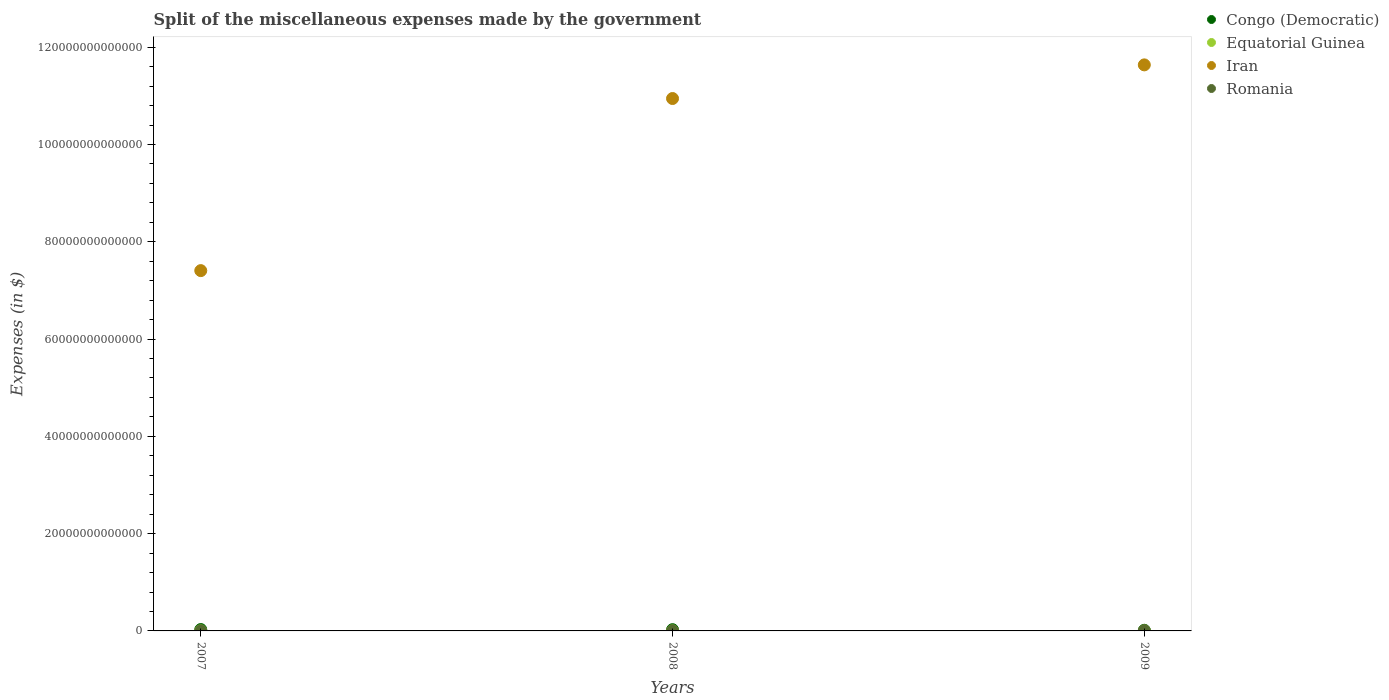What is the miscellaneous expenses made by the government in Iran in 2009?
Keep it short and to the point. 1.16e+14. Across all years, what is the maximum miscellaneous expenses made by the government in Congo (Democratic)?
Ensure brevity in your answer.  2.81e+11. Across all years, what is the minimum miscellaneous expenses made by the government in Romania?
Make the answer very short. 1.36e+1. In which year was the miscellaneous expenses made by the government in Romania maximum?
Give a very brief answer. 2009. In which year was the miscellaneous expenses made by the government in Congo (Democratic) minimum?
Provide a succinct answer. 2009. What is the total miscellaneous expenses made by the government in Equatorial Guinea in the graph?
Your answer should be compact. 2.29e+1. What is the difference between the miscellaneous expenses made by the government in Equatorial Guinea in 2007 and that in 2008?
Provide a succinct answer. -5.30e+07. What is the difference between the miscellaneous expenses made by the government in Equatorial Guinea in 2007 and the miscellaneous expenses made by the government in Romania in 2008?
Your answer should be very brief. -4.41e+09. What is the average miscellaneous expenses made by the government in Romania per year?
Your response must be concise. 2.50e+1. In the year 2008, what is the difference between the miscellaneous expenses made by the government in Iran and miscellaneous expenses made by the government in Equatorial Guinea?
Offer a very short reply. 1.09e+14. In how many years, is the miscellaneous expenses made by the government in Equatorial Guinea greater than 44000000000000 $?
Your answer should be very brief. 0. What is the ratio of the miscellaneous expenses made by the government in Romania in 2007 to that in 2009?
Give a very brief answer. 0.31. Is the miscellaneous expenses made by the government in Congo (Democratic) in 2007 less than that in 2008?
Provide a succinct answer. No. What is the difference between the highest and the second highest miscellaneous expenses made by the government in Congo (Democratic)?
Offer a very short reply. 2.54e+1. What is the difference between the highest and the lowest miscellaneous expenses made by the government in Congo (Democratic)?
Offer a terse response. 1.52e+11. Is the sum of the miscellaneous expenses made by the government in Iran in 2007 and 2009 greater than the maximum miscellaneous expenses made by the government in Congo (Democratic) across all years?
Provide a short and direct response. Yes. Is it the case that in every year, the sum of the miscellaneous expenses made by the government in Congo (Democratic) and miscellaneous expenses made by the government in Equatorial Guinea  is greater than the sum of miscellaneous expenses made by the government in Romania and miscellaneous expenses made by the government in Iran?
Give a very brief answer. Yes. Is it the case that in every year, the sum of the miscellaneous expenses made by the government in Congo (Democratic) and miscellaneous expenses made by the government in Iran  is greater than the miscellaneous expenses made by the government in Equatorial Guinea?
Your response must be concise. Yes. Does the miscellaneous expenses made by the government in Congo (Democratic) monotonically increase over the years?
Provide a short and direct response. No. How many dotlines are there?
Offer a very short reply. 4. What is the difference between two consecutive major ticks on the Y-axis?
Provide a succinct answer. 2.00e+13. Are the values on the major ticks of Y-axis written in scientific E-notation?
Provide a short and direct response. No. Does the graph contain grids?
Offer a very short reply. No. What is the title of the graph?
Offer a terse response. Split of the miscellaneous expenses made by the government. Does "Finland" appear as one of the legend labels in the graph?
Make the answer very short. No. What is the label or title of the X-axis?
Provide a short and direct response. Years. What is the label or title of the Y-axis?
Keep it short and to the point. Expenses (in $). What is the Expenses (in $) in Congo (Democratic) in 2007?
Give a very brief answer. 2.81e+11. What is the Expenses (in $) of Equatorial Guinea in 2007?
Provide a succinct answer. 9.16e+09. What is the Expenses (in $) in Iran in 2007?
Make the answer very short. 7.41e+13. What is the Expenses (in $) of Romania in 2007?
Keep it short and to the point. 1.45e+1. What is the Expenses (in $) of Congo (Democratic) in 2008?
Offer a very short reply. 2.56e+11. What is the Expenses (in $) in Equatorial Guinea in 2008?
Ensure brevity in your answer.  9.21e+09. What is the Expenses (in $) in Iran in 2008?
Keep it short and to the point. 1.09e+14. What is the Expenses (in $) in Romania in 2008?
Make the answer very short. 1.36e+1. What is the Expenses (in $) in Congo (Democratic) in 2009?
Make the answer very short. 1.29e+11. What is the Expenses (in $) of Equatorial Guinea in 2009?
Your answer should be compact. 4.52e+09. What is the Expenses (in $) in Iran in 2009?
Give a very brief answer. 1.16e+14. What is the Expenses (in $) of Romania in 2009?
Your response must be concise. 4.70e+1. Across all years, what is the maximum Expenses (in $) in Congo (Democratic)?
Offer a terse response. 2.81e+11. Across all years, what is the maximum Expenses (in $) of Equatorial Guinea?
Offer a terse response. 9.21e+09. Across all years, what is the maximum Expenses (in $) of Iran?
Offer a terse response. 1.16e+14. Across all years, what is the maximum Expenses (in $) in Romania?
Your answer should be very brief. 4.70e+1. Across all years, what is the minimum Expenses (in $) in Congo (Democratic)?
Provide a succinct answer. 1.29e+11. Across all years, what is the minimum Expenses (in $) of Equatorial Guinea?
Ensure brevity in your answer.  4.52e+09. Across all years, what is the minimum Expenses (in $) in Iran?
Keep it short and to the point. 7.41e+13. Across all years, what is the minimum Expenses (in $) of Romania?
Your answer should be very brief. 1.36e+1. What is the total Expenses (in $) in Congo (Democratic) in the graph?
Give a very brief answer. 6.66e+11. What is the total Expenses (in $) in Equatorial Guinea in the graph?
Offer a terse response. 2.29e+1. What is the total Expenses (in $) of Iran in the graph?
Offer a terse response. 3.00e+14. What is the total Expenses (in $) in Romania in the graph?
Ensure brevity in your answer.  7.51e+1. What is the difference between the Expenses (in $) of Congo (Democratic) in 2007 and that in 2008?
Ensure brevity in your answer.  2.54e+1. What is the difference between the Expenses (in $) in Equatorial Guinea in 2007 and that in 2008?
Ensure brevity in your answer.  -5.30e+07. What is the difference between the Expenses (in $) in Iran in 2007 and that in 2008?
Ensure brevity in your answer.  -3.54e+13. What is the difference between the Expenses (in $) of Romania in 2007 and that in 2008?
Provide a short and direct response. 9.48e+08. What is the difference between the Expenses (in $) of Congo (Democratic) in 2007 and that in 2009?
Ensure brevity in your answer.  1.52e+11. What is the difference between the Expenses (in $) in Equatorial Guinea in 2007 and that in 2009?
Ensure brevity in your answer.  4.63e+09. What is the difference between the Expenses (in $) in Iran in 2007 and that in 2009?
Your response must be concise. -4.23e+13. What is the difference between the Expenses (in $) of Romania in 2007 and that in 2009?
Offer a terse response. -3.25e+1. What is the difference between the Expenses (in $) of Congo (Democratic) in 2008 and that in 2009?
Your answer should be compact. 1.27e+11. What is the difference between the Expenses (in $) in Equatorial Guinea in 2008 and that in 2009?
Keep it short and to the point. 4.69e+09. What is the difference between the Expenses (in $) of Iran in 2008 and that in 2009?
Your answer should be very brief. -6.92e+12. What is the difference between the Expenses (in $) of Romania in 2008 and that in 2009?
Keep it short and to the point. -3.34e+1. What is the difference between the Expenses (in $) of Congo (Democratic) in 2007 and the Expenses (in $) of Equatorial Guinea in 2008?
Keep it short and to the point. 2.72e+11. What is the difference between the Expenses (in $) in Congo (Democratic) in 2007 and the Expenses (in $) in Iran in 2008?
Offer a very short reply. -1.09e+14. What is the difference between the Expenses (in $) of Congo (Democratic) in 2007 and the Expenses (in $) of Romania in 2008?
Make the answer very short. 2.67e+11. What is the difference between the Expenses (in $) of Equatorial Guinea in 2007 and the Expenses (in $) of Iran in 2008?
Offer a terse response. -1.09e+14. What is the difference between the Expenses (in $) in Equatorial Guinea in 2007 and the Expenses (in $) in Romania in 2008?
Offer a terse response. -4.41e+09. What is the difference between the Expenses (in $) in Iran in 2007 and the Expenses (in $) in Romania in 2008?
Your response must be concise. 7.41e+13. What is the difference between the Expenses (in $) in Congo (Democratic) in 2007 and the Expenses (in $) in Equatorial Guinea in 2009?
Give a very brief answer. 2.76e+11. What is the difference between the Expenses (in $) of Congo (Democratic) in 2007 and the Expenses (in $) of Iran in 2009?
Your response must be concise. -1.16e+14. What is the difference between the Expenses (in $) in Congo (Democratic) in 2007 and the Expenses (in $) in Romania in 2009?
Offer a terse response. 2.34e+11. What is the difference between the Expenses (in $) of Equatorial Guinea in 2007 and the Expenses (in $) of Iran in 2009?
Your answer should be compact. -1.16e+14. What is the difference between the Expenses (in $) in Equatorial Guinea in 2007 and the Expenses (in $) in Romania in 2009?
Make the answer very short. -3.78e+1. What is the difference between the Expenses (in $) in Iran in 2007 and the Expenses (in $) in Romania in 2009?
Ensure brevity in your answer.  7.40e+13. What is the difference between the Expenses (in $) in Congo (Democratic) in 2008 and the Expenses (in $) in Equatorial Guinea in 2009?
Your answer should be very brief. 2.51e+11. What is the difference between the Expenses (in $) of Congo (Democratic) in 2008 and the Expenses (in $) of Iran in 2009?
Your answer should be compact. -1.16e+14. What is the difference between the Expenses (in $) of Congo (Democratic) in 2008 and the Expenses (in $) of Romania in 2009?
Your response must be concise. 2.09e+11. What is the difference between the Expenses (in $) of Equatorial Guinea in 2008 and the Expenses (in $) of Iran in 2009?
Give a very brief answer. -1.16e+14. What is the difference between the Expenses (in $) in Equatorial Guinea in 2008 and the Expenses (in $) in Romania in 2009?
Keep it short and to the point. -3.78e+1. What is the difference between the Expenses (in $) of Iran in 2008 and the Expenses (in $) of Romania in 2009?
Offer a terse response. 1.09e+14. What is the average Expenses (in $) in Congo (Democratic) per year?
Keep it short and to the point. 2.22e+11. What is the average Expenses (in $) of Equatorial Guinea per year?
Offer a very short reply. 7.63e+09. What is the average Expenses (in $) in Iran per year?
Your answer should be very brief. 1.00e+14. What is the average Expenses (in $) in Romania per year?
Ensure brevity in your answer.  2.50e+1. In the year 2007, what is the difference between the Expenses (in $) in Congo (Democratic) and Expenses (in $) in Equatorial Guinea?
Ensure brevity in your answer.  2.72e+11. In the year 2007, what is the difference between the Expenses (in $) in Congo (Democratic) and Expenses (in $) in Iran?
Provide a succinct answer. -7.38e+13. In the year 2007, what is the difference between the Expenses (in $) in Congo (Democratic) and Expenses (in $) in Romania?
Your response must be concise. 2.66e+11. In the year 2007, what is the difference between the Expenses (in $) in Equatorial Guinea and Expenses (in $) in Iran?
Provide a succinct answer. -7.41e+13. In the year 2007, what is the difference between the Expenses (in $) of Equatorial Guinea and Expenses (in $) of Romania?
Your answer should be very brief. -5.36e+09. In the year 2007, what is the difference between the Expenses (in $) in Iran and Expenses (in $) in Romania?
Ensure brevity in your answer.  7.41e+13. In the year 2008, what is the difference between the Expenses (in $) in Congo (Democratic) and Expenses (in $) in Equatorial Guinea?
Your answer should be compact. 2.46e+11. In the year 2008, what is the difference between the Expenses (in $) of Congo (Democratic) and Expenses (in $) of Iran?
Ensure brevity in your answer.  -1.09e+14. In the year 2008, what is the difference between the Expenses (in $) of Congo (Democratic) and Expenses (in $) of Romania?
Offer a terse response. 2.42e+11. In the year 2008, what is the difference between the Expenses (in $) in Equatorial Guinea and Expenses (in $) in Iran?
Ensure brevity in your answer.  -1.09e+14. In the year 2008, what is the difference between the Expenses (in $) in Equatorial Guinea and Expenses (in $) in Romania?
Your answer should be very brief. -4.36e+09. In the year 2008, what is the difference between the Expenses (in $) in Iran and Expenses (in $) in Romania?
Offer a very short reply. 1.09e+14. In the year 2009, what is the difference between the Expenses (in $) of Congo (Democratic) and Expenses (in $) of Equatorial Guinea?
Ensure brevity in your answer.  1.24e+11. In the year 2009, what is the difference between the Expenses (in $) in Congo (Democratic) and Expenses (in $) in Iran?
Your answer should be compact. -1.16e+14. In the year 2009, what is the difference between the Expenses (in $) of Congo (Democratic) and Expenses (in $) of Romania?
Your answer should be compact. 8.20e+1. In the year 2009, what is the difference between the Expenses (in $) of Equatorial Guinea and Expenses (in $) of Iran?
Ensure brevity in your answer.  -1.16e+14. In the year 2009, what is the difference between the Expenses (in $) in Equatorial Guinea and Expenses (in $) in Romania?
Give a very brief answer. -4.25e+1. In the year 2009, what is the difference between the Expenses (in $) of Iran and Expenses (in $) of Romania?
Offer a very short reply. 1.16e+14. What is the ratio of the Expenses (in $) of Congo (Democratic) in 2007 to that in 2008?
Ensure brevity in your answer.  1.1. What is the ratio of the Expenses (in $) in Iran in 2007 to that in 2008?
Your answer should be compact. 0.68. What is the ratio of the Expenses (in $) of Romania in 2007 to that in 2008?
Offer a terse response. 1.07. What is the ratio of the Expenses (in $) of Congo (Democratic) in 2007 to that in 2009?
Your answer should be compact. 2.18. What is the ratio of the Expenses (in $) of Equatorial Guinea in 2007 to that in 2009?
Your answer should be very brief. 2.02. What is the ratio of the Expenses (in $) in Iran in 2007 to that in 2009?
Offer a terse response. 0.64. What is the ratio of the Expenses (in $) in Romania in 2007 to that in 2009?
Provide a short and direct response. 0.31. What is the ratio of the Expenses (in $) of Congo (Democratic) in 2008 to that in 2009?
Provide a succinct answer. 1.98. What is the ratio of the Expenses (in $) of Equatorial Guinea in 2008 to that in 2009?
Make the answer very short. 2.04. What is the ratio of the Expenses (in $) of Iran in 2008 to that in 2009?
Your answer should be compact. 0.94. What is the ratio of the Expenses (in $) of Romania in 2008 to that in 2009?
Offer a terse response. 0.29. What is the difference between the highest and the second highest Expenses (in $) of Congo (Democratic)?
Keep it short and to the point. 2.54e+1. What is the difference between the highest and the second highest Expenses (in $) in Equatorial Guinea?
Give a very brief answer. 5.30e+07. What is the difference between the highest and the second highest Expenses (in $) in Iran?
Provide a succinct answer. 6.92e+12. What is the difference between the highest and the second highest Expenses (in $) of Romania?
Ensure brevity in your answer.  3.25e+1. What is the difference between the highest and the lowest Expenses (in $) of Congo (Democratic)?
Make the answer very short. 1.52e+11. What is the difference between the highest and the lowest Expenses (in $) of Equatorial Guinea?
Give a very brief answer. 4.69e+09. What is the difference between the highest and the lowest Expenses (in $) in Iran?
Offer a terse response. 4.23e+13. What is the difference between the highest and the lowest Expenses (in $) of Romania?
Make the answer very short. 3.34e+1. 